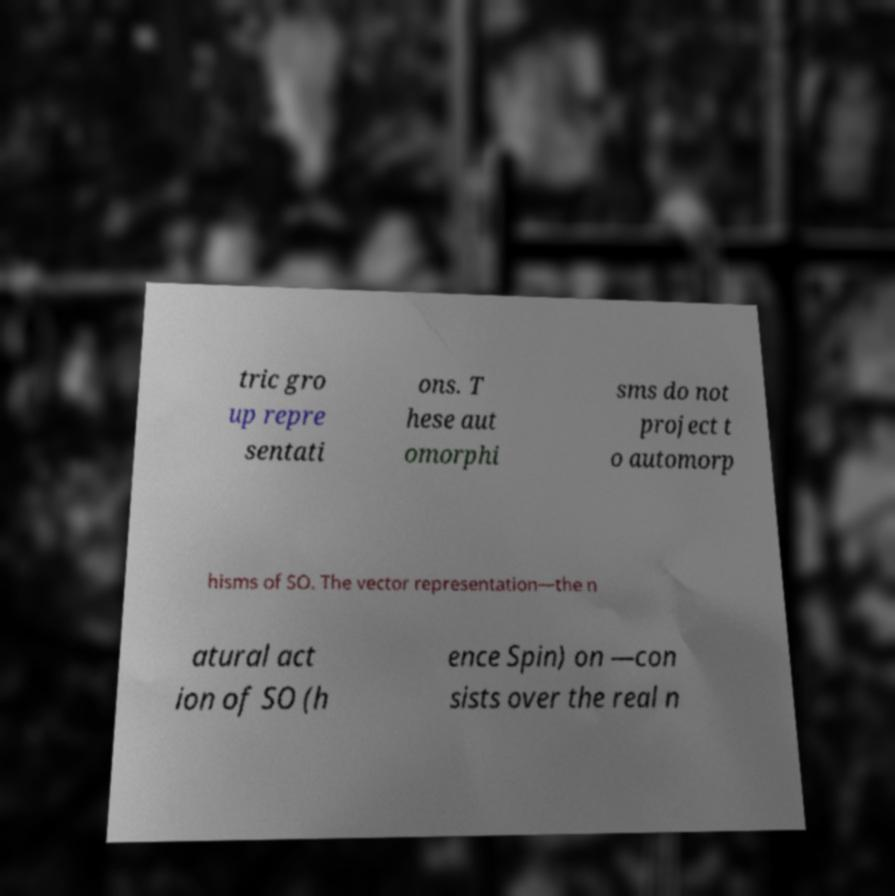Could you extract and type out the text from this image? tric gro up repre sentati ons. T hese aut omorphi sms do not project t o automorp hisms of SO. The vector representation—the n atural act ion of SO (h ence Spin) on —con sists over the real n 